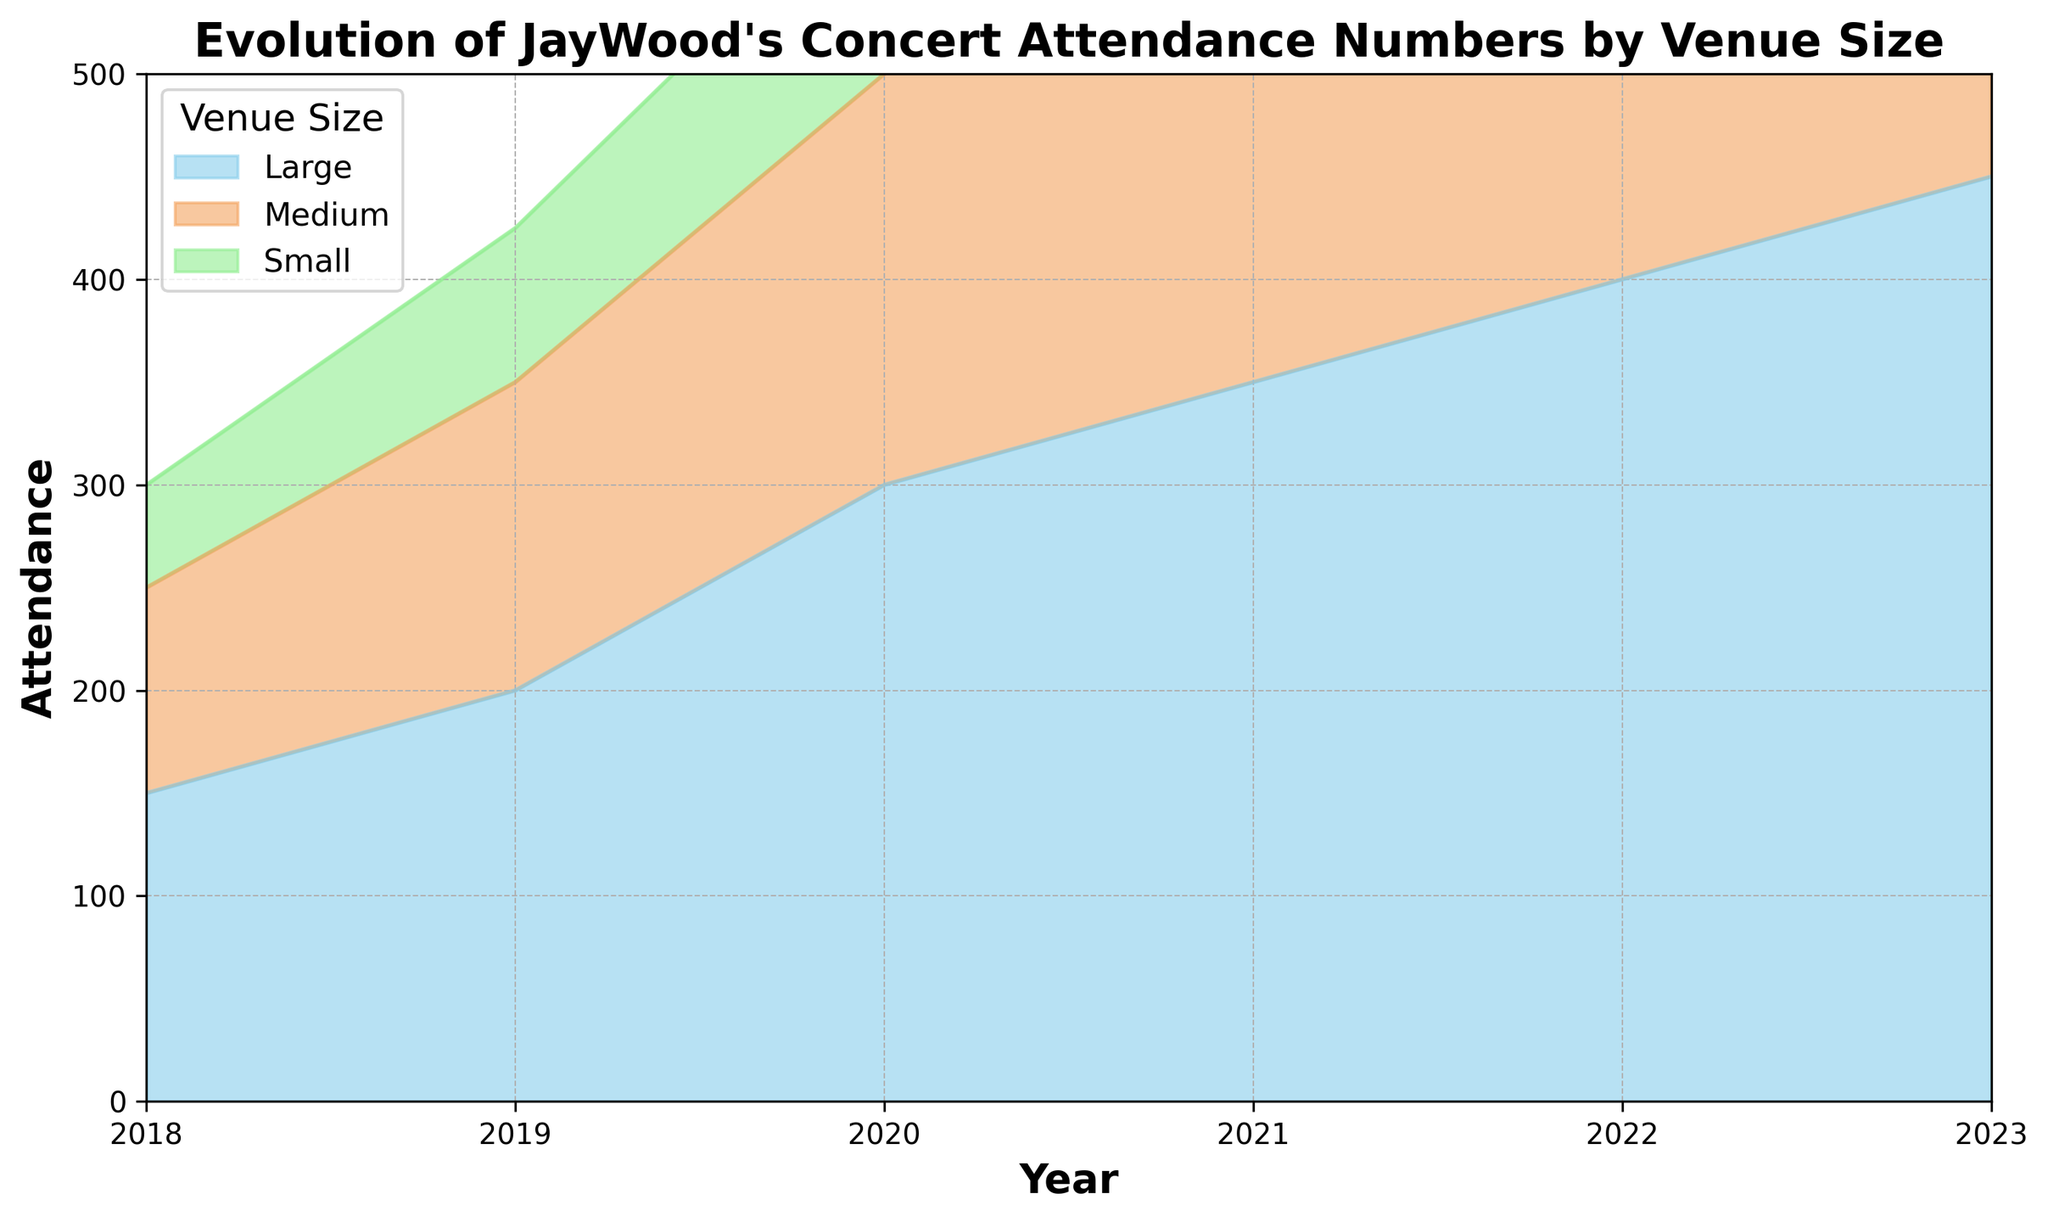What's the total concert attendance in 2018? To find the total attendance in 2018, sum the attendance numbers for all venue sizes in that year: 50 (Small) + 100 (Medium) + 150 (Large) = 300.
Answer: 300 How did the attendance for Medium-sized venues change from 2018 to 2023? Attendance for Medium-sized venues in 2018 was 100. By 2023, it increased to 350. The change is 350 - 100 = 250.
Answer: Increased by 250 Which venue size had the greatest increase in attendance from 2018 to 2023? Calculate the difference in attendance for each venue size from 2018 to 2023. Small: 160 - 50 = 110, Medium: 350 - 100 = 250, Large: 450 - 150 = 300. The greatest increase is in Large venues with 300.
Answer: Large In which year did Small-sized venues see the highest attendance? By inspecting the area heights for each year, Small-sized venues had the highest attendance in 2023, with 160 attendees.
Answer: 2023 What was the average attendance for Large-sized venues across all years? Sum the attendance for Large-sized venues across all years and divide by the number of years: (150 + 200 + 300 + 350 + 400 + 450) / 6 = 1850 / 6 ≈ 308.33.
Answer: 308.33 Are there any years where the total attendance across all venue sizes is equal to 500? Calculate the total attendance for each year and check for 500: 2018 = 300, 2019 = 425, 2020 = 600, 2021 = 720, 2022 = 840, 2023 = 960. No year equals 500.
Answer: No Which year had the lowest total concert attendance? Calculate the total attendance for each year and find the lowest: 2018 = 300, 2019 = 425, 2020 = 600, 2021 = 720, 2022 = 840, 2023 = 960. The lowest total is 2018 with 300.
Answer: 2018 In terms of visual attributes, how can you describe the trend in attendance for Large venues over the years? The area representing Large venues consistently increases in size from 2018 to 2023, indicating a steady growth in attendance.
Answer: Steady growth What is the difference in attendance between Small and Large venues in 2022? Attendance in 2022 for Small venues is 140 and for Large venues is 400. The difference is 400 - 140 = 260.
Answer: 260 How does the attendance trend for Small venues compare to Medium venues from 2018 to 2023? Both venue sizes show an increase in attendance from 2018 to 2023. For Small venues, it went from 50 to 160; for Medium, from 100 to 350. Both exhibit growth, with Medium venues showing a larger numerical increase.
Answer: Both increased; Medium had a larger increase 